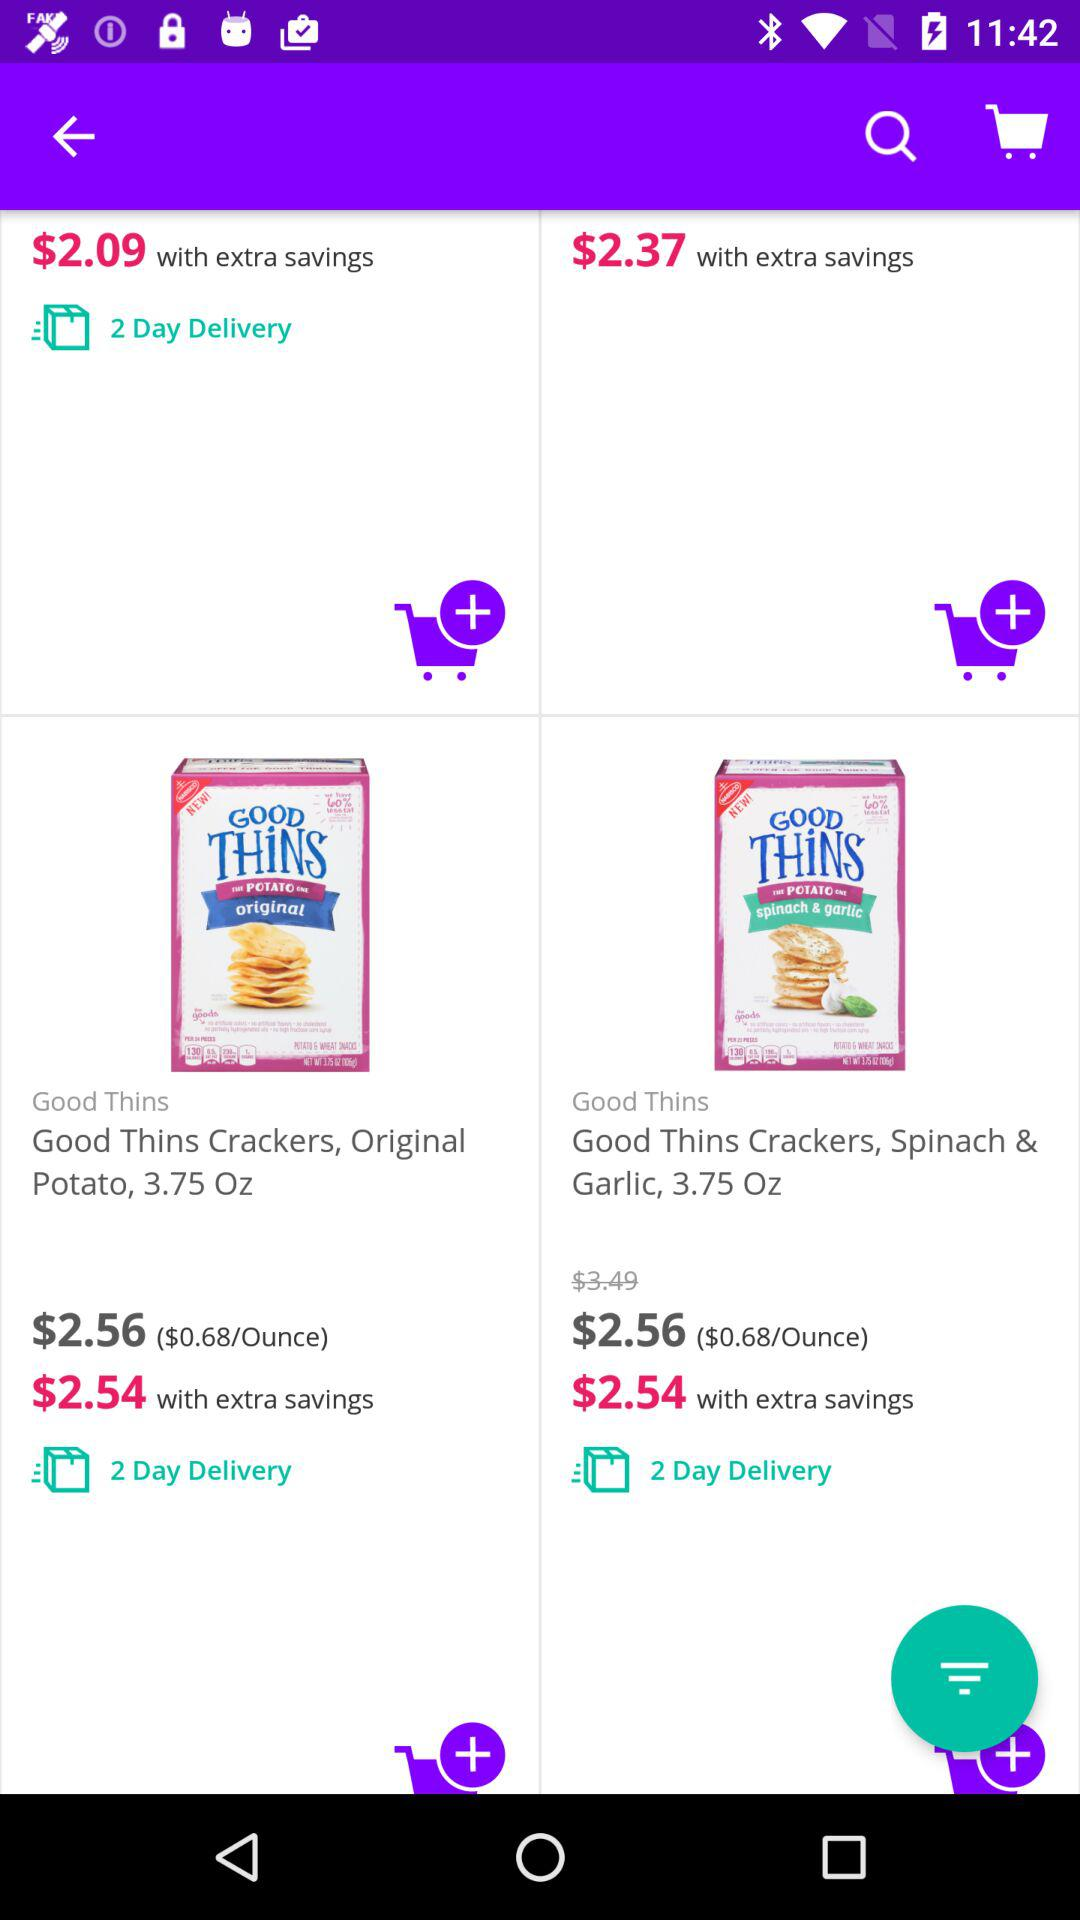How much will the price be with the extra savings? The price will be $2.54 with the extra savings. 